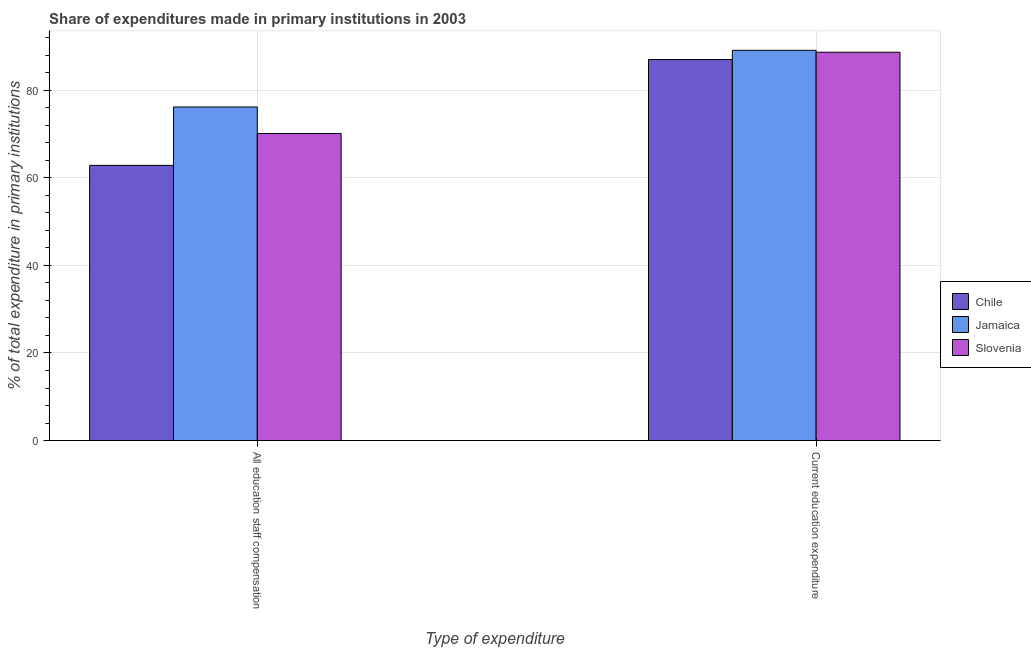How many different coloured bars are there?
Offer a terse response. 3. Are the number of bars on each tick of the X-axis equal?
Your answer should be very brief. Yes. How many bars are there on the 2nd tick from the right?
Give a very brief answer. 3. What is the label of the 1st group of bars from the left?
Provide a short and direct response. All education staff compensation. What is the expenditure in education in Slovenia?
Your answer should be compact. 88.66. Across all countries, what is the maximum expenditure in staff compensation?
Your answer should be compact. 76.16. Across all countries, what is the minimum expenditure in education?
Make the answer very short. 86.99. In which country was the expenditure in staff compensation maximum?
Your response must be concise. Jamaica. In which country was the expenditure in education minimum?
Make the answer very short. Chile. What is the total expenditure in staff compensation in the graph?
Provide a succinct answer. 209.08. What is the difference between the expenditure in education in Slovenia and that in Jamaica?
Give a very brief answer. -0.43. What is the difference between the expenditure in staff compensation in Jamaica and the expenditure in education in Chile?
Your answer should be compact. -10.83. What is the average expenditure in staff compensation per country?
Your response must be concise. 69.69. What is the difference between the expenditure in staff compensation and expenditure in education in Jamaica?
Your response must be concise. -12.93. In how many countries, is the expenditure in education greater than 8 %?
Provide a short and direct response. 3. What is the ratio of the expenditure in education in Jamaica to that in Chile?
Make the answer very short. 1.02. Is the expenditure in staff compensation in Jamaica less than that in Slovenia?
Your answer should be very brief. No. In how many countries, is the expenditure in education greater than the average expenditure in education taken over all countries?
Offer a terse response. 2. What does the 2nd bar from the left in All education staff compensation represents?
Your answer should be very brief. Jamaica. How many bars are there?
Ensure brevity in your answer.  6. Are the values on the major ticks of Y-axis written in scientific E-notation?
Keep it short and to the point. No. Where does the legend appear in the graph?
Keep it short and to the point. Center right. What is the title of the graph?
Give a very brief answer. Share of expenditures made in primary institutions in 2003. Does "Peru" appear as one of the legend labels in the graph?
Offer a terse response. No. What is the label or title of the X-axis?
Provide a succinct answer. Type of expenditure. What is the label or title of the Y-axis?
Keep it short and to the point. % of total expenditure in primary institutions. What is the % of total expenditure in primary institutions of Chile in All education staff compensation?
Ensure brevity in your answer.  62.82. What is the % of total expenditure in primary institutions in Jamaica in All education staff compensation?
Provide a succinct answer. 76.16. What is the % of total expenditure in primary institutions of Slovenia in All education staff compensation?
Offer a terse response. 70.1. What is the % of total expenditure in primary institutions of Chile in Current education expenditure?
Your response must be concise. 86.99. What is the % of total expenditure in primary institutions in Jamaica in Current education expenditure?
Your answer should be very brief. 89.09. What is the % of total expenditure in primary institutions in Slovenia in Current education expenditure?
Your response must be concise. 88.66. Across all Type of expenditure, what is the maximum % of total expenditure in primary institutions in Chile?
Provide a short and direct response. 86.99. Across all Type of expenditure, what is the maximum % of total expenditure in primary institutions of Jamaica?
Your response must be concise. 89.09. Across all Type of expenditure, what is the maximum % of total expenditure in primary institutions of Slovenia?
Your response must be concise. 88.66. Across all Type of expenditure, what is the minimum % of total expenditure in primary institutions of Chile?
Your response must be concise. 62.82. Across all Type of expenditure, what is the minimum % of total expenditure in primary institutions in Jamaica?
Ensure brevity in your answer.  76.16. Across all Type of expenditure, what is the minimum % of total expenditure in primary institutions in Slovenia?
Offer a terse response. 70.1. What is the total % of total expenditure in primary institutions of Chile in the graph?
Your answer should be compact. 149.81. What is the total % of total expenditure in primary institutions of Jamaica in the graph?
Provide a short and direct response. 165.24. What is the total % of total expenditure in primary institutions of Slovenia in the graph?
Your answer should be very brief. 158.76. What is the difference between the % of total expenditure in primary institutions of Chile in All education staff compensation and that in Current education expenditure?
Give a very brief answer. -24.16. What is the difference between the % of total expenditure in primary institutions in Jamaica in All education staff compensation and that in Current education expenditure?
Your answer should be very brief. -12.93. What is the difference between the % of total expenditure in primary institutions in Slovenia in All education staff compensation and that in Current education expenditure?
Your response must be concise. -18.55. What is the difference between the % of total expenditure in primary institutions of Chile in All education staff compensation and the % of total expenditure in primary institutions of Jamaica in Current education expenditure?
Ensure brevity in your answer.  -26.26. What is the difference between the % of total expenditure in primary institutions in Chile in All education staff compensation and the % of total expenditure in primary institutions in Slovenia in Current education expenditure?
Make the answer very short. -25.83. What is the difference between the % of total expenditure in primary institutions in Jamaica in All education staff compensation and the % of total expenditure in primary institutions in Slovenia in Current education expenditure?
Provide a succinct answer. -12.5. What is the average % of total expenditure in primary institutions of Chile per Type of expenditure?
Your answer should be very brief. 74.91. What is the average % of total expenditure in primary institutions in Jamaica per Type of expenditure?
Make the answer very short. 82.62. What is the average % of total expenditure in primary institutions in Slovenia per Type of expenditure?
Make the answer very short. 79.38. What is the difference between the % of total expenditure in primary institutions of Chile and % of total expenditure in primary institutions of Jamaica in All education staff compensation?
Keep it short and to the point. -13.33. What is the difference between the % of total expenditure in primary institutions of Chile and % of total expenditure in primary institutions of Slovenia in All education staff compensation?
Ensure brevity in your answer.  -7.28. What is the difference between the % of total expenditure in primary institutions in Jamaica and % of total expenditure in primary institutions in Slovenia in All education staff compensation?
Your response must be concise. 6.05. What is the difference between the % of total expenditure in primary institutions in Chile and % of total expenditure in primary institutions in Jamaica in Current education expenditure?
Offer a very short reply. -2.1. What is the difference between the % of total expenditure in primary institutions in Chile and % of total expenditure in primary institutions in Slovenia in Current education expenditure?
Provide a short and direct response. -1.67. What is the difference between the % of total expenditure in primary institutions in Jamaica and % of total expenditure in primary institutions in Slovenia in Current education expenditure?
Make the answer very short. 0.43. What is the ratio of the % of total expenditure in primary institutions in Chile in All education staff compensation to that in Current education expenditure?
Offer a very short reply. 0.72. What is the ratio of the % of total expenditure in primary institutions in Jamaica in All education staff compensation to that in Current education expenditure?
Ensure brevity in your answer.  0.85. What is the ratio of the % of total expenditure in primary institutions of Slovenia in All education staff compensation to that in Current education expenditure?
Ensure brevity in your answer.  0.79. What is the difference between the highest and the second highest % of total expenditure in primary institutions of Chile?
Your answer should be very brief. 24.16. What is the difference between the highest and the second highest % of total expenditure in primary institutions of Jamaica?
Your response must be concise. 12.93. What is the difference between the highest and the second highest % of total expenditure in primary institutions in Slovenia?
Your response must be concise. 18.55. What is the difference between the highest and the lowest % of total expenditure in primary institutions of Chile?
Make the answer very short. 24.16. What is the difference between the highest and the lowest % of total expenditure in primary institutions of Jamaica?
Offer a terse response. 12.93. What is the difference between the highest and the lowest % of total expenditure in primary institutions of Slovenia?
Your answer should be very brief. 18.55. 